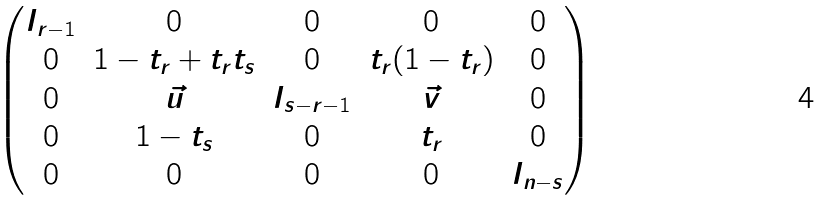Convert formula to latex. <formula><loc_0><loc_0><loc_500><loc_500>\begin{pmatrix} I _ { r - 1 } & 0 & 0 & 0 & 0 \\ 0 & 1 - t _ { r } + t _ { r } t _ { s } & 0 & t _ { r } ( 1 - t _ { r } ) & 0 \\ 0 & \vec { u } & I _ { s - r - 1 } & \vec { v } & 0 \\ 0 & 1 - t _ { s } & 0 & t _ { r } & 0 \\ 0 & 0 & 0 & 0 & I _ { n - s } \end{pmatrix}</formula> 